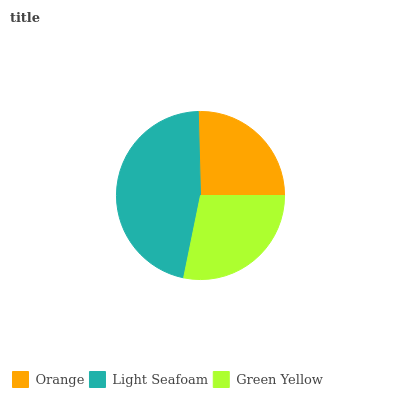Is Orange the minimum?
Answer yes or no. Yes. Is Light Seafoam the maximum?
Answer yes or no. Yes. Is Green Yellow the minimum?
Answer yes or no. No. Is Green Yellow the maximum?
Answer yes or no. No. Is Light Seafoam greater than Green Yellow?
Answer yes or no. Yes. Is Green Yellow less than Light Seafoam?
Answer yes or no. Yes. Is Green Yellow greater than Light Seafoam?
Answer yes or no. No. Is Light Seafoam less than Green Yellow?
Answer yes or no. No. Is Green Yellow the high median?
Answer yes or no. Yes. Is Green Yellow the low median?
Answer yes or no. Yes. Is Orange the high median?
Answer yes or no. No. Is Orange the low median?
Answer yes or no. No. 